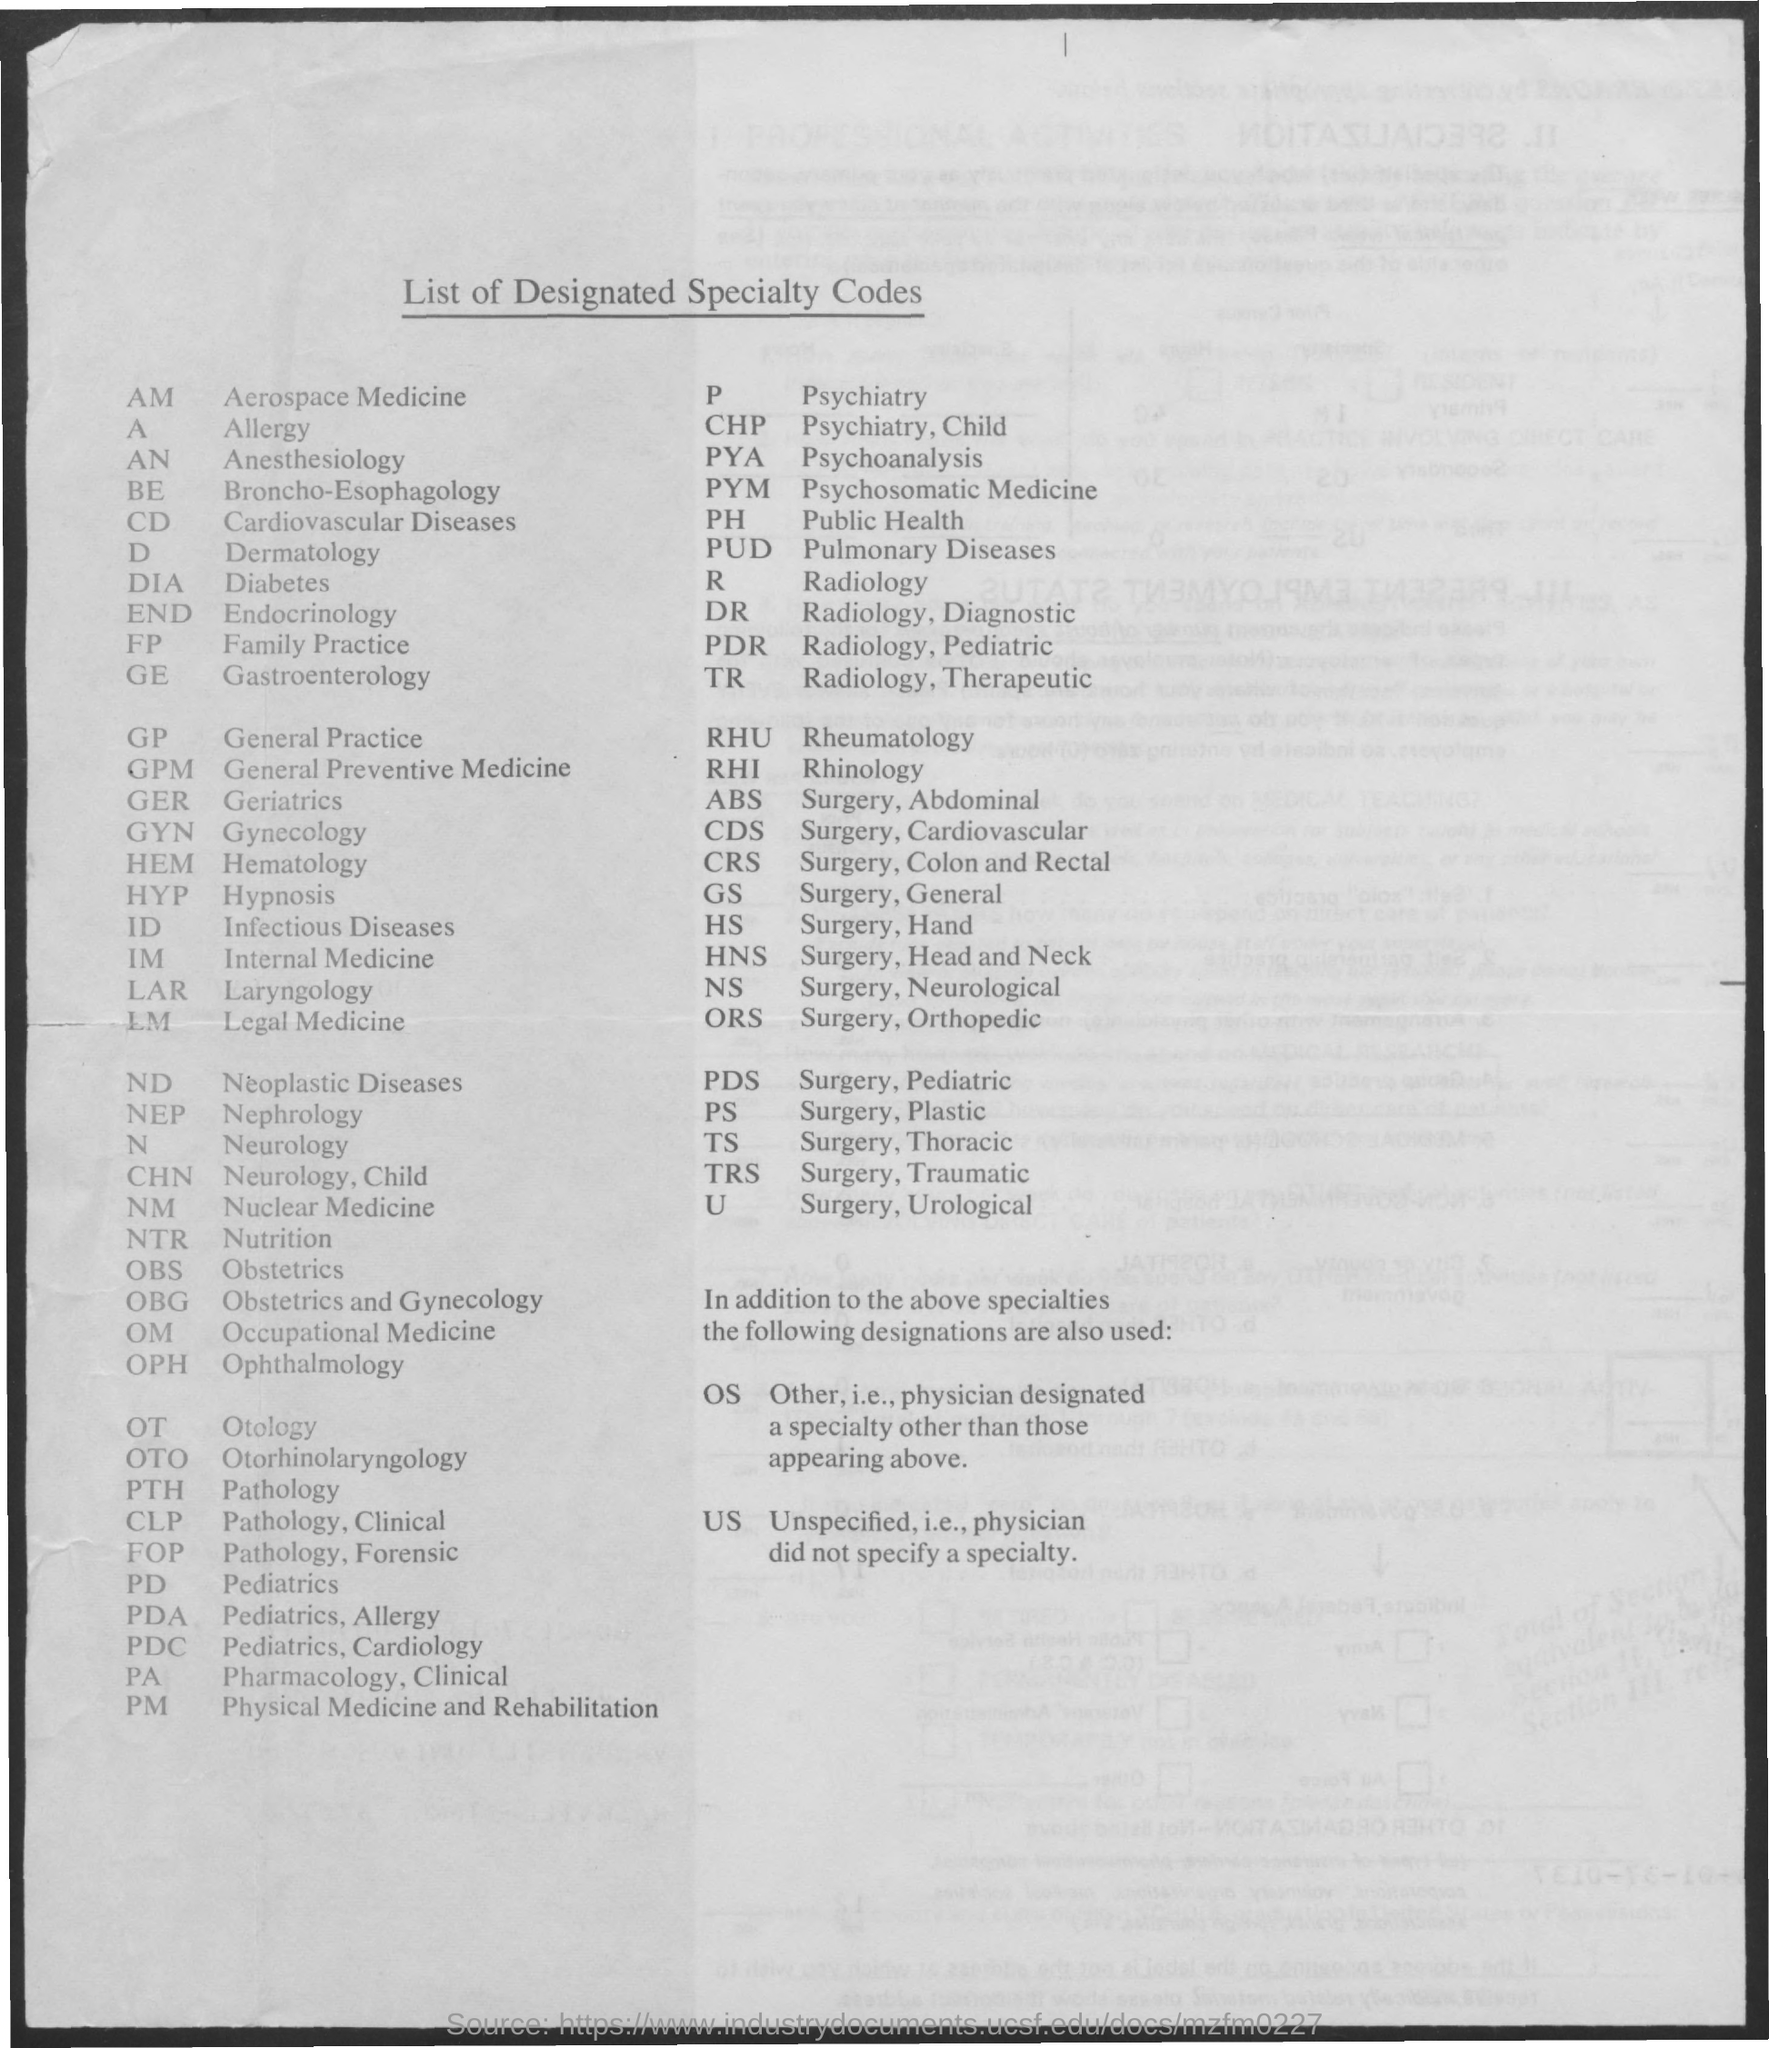Mention a couple of crucial points in this snapshot. General practice refers to the branch of medicine that focuses on providing comprehensive and continuing medical care to individuals and families, regardless of their age or sex. It encompasses the diagnosis and treatment of acute and chronic illnesses, as well as preventive care, health education, and maintenance of health. I declare that the full form of FP is Family Practice. The abbreviation 'A' is used as an acronym for the word 'allergy'. 